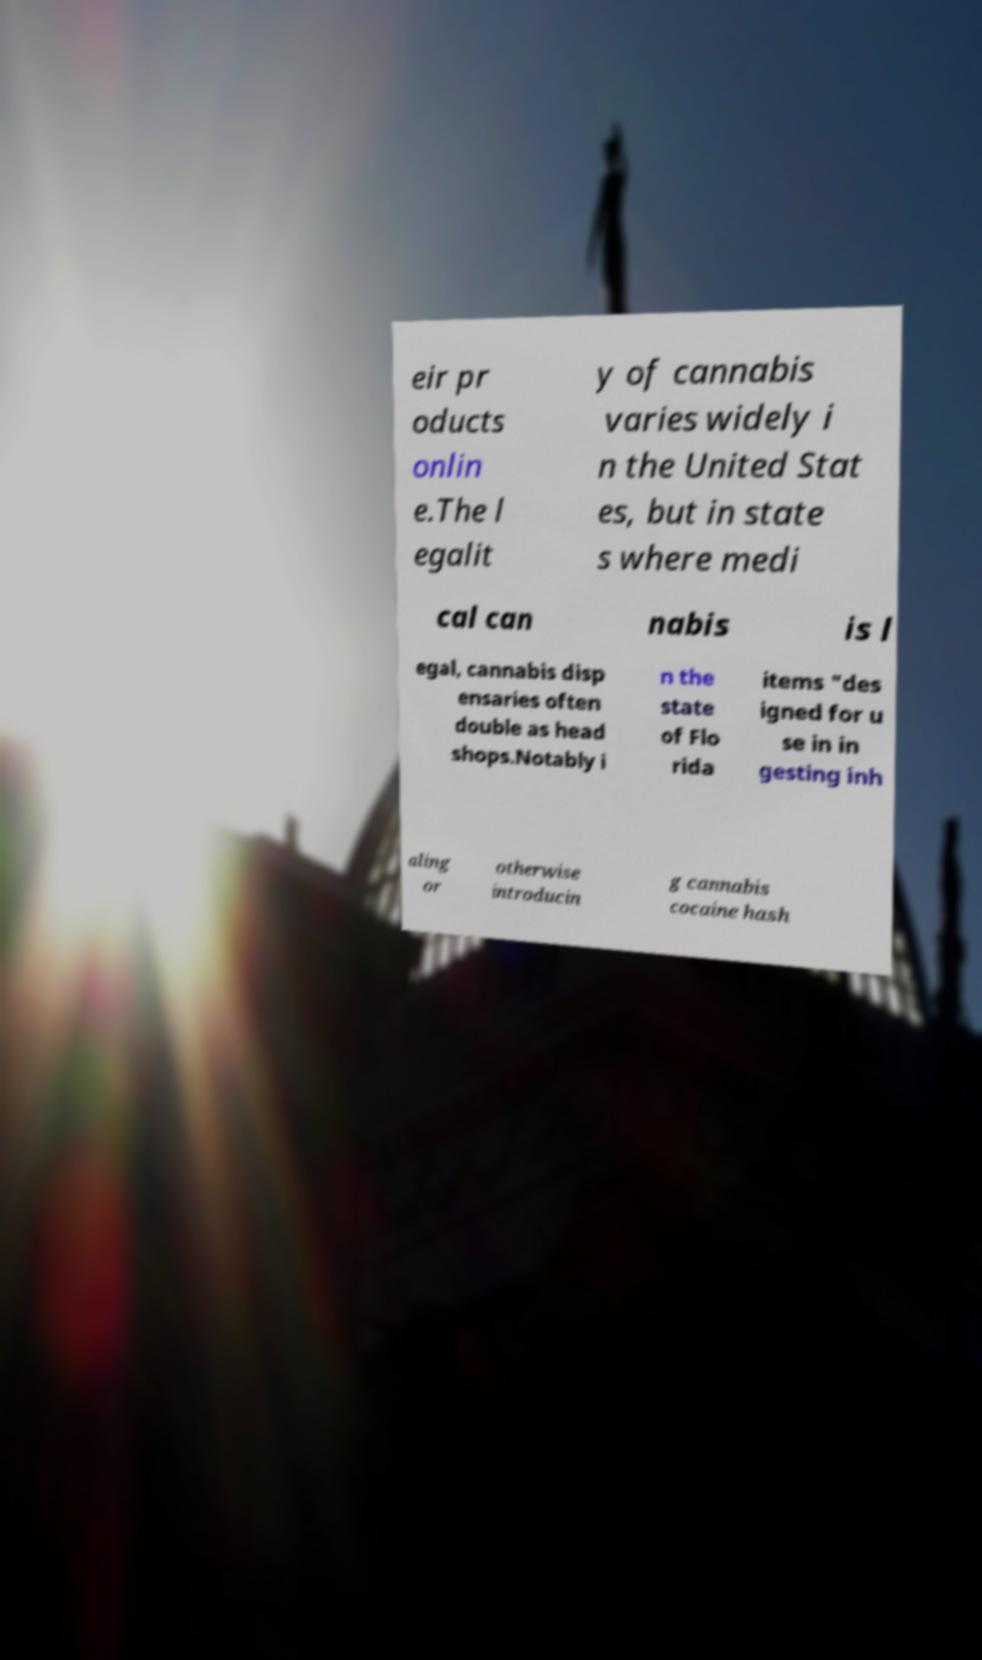Can you accurately transcribe the text from the provided image for me? eir pr oducts onlin e.The l egalit y of cannabis varies widely i n the United Stat es, but in state s where medi cal can nabis is l egal, cannabis disp ensaries often double as head shops.Notably i n the state of Flo rida items "des igned for u se in in gesting inh aling or otherwise introducin g cannabis cocaine hash 